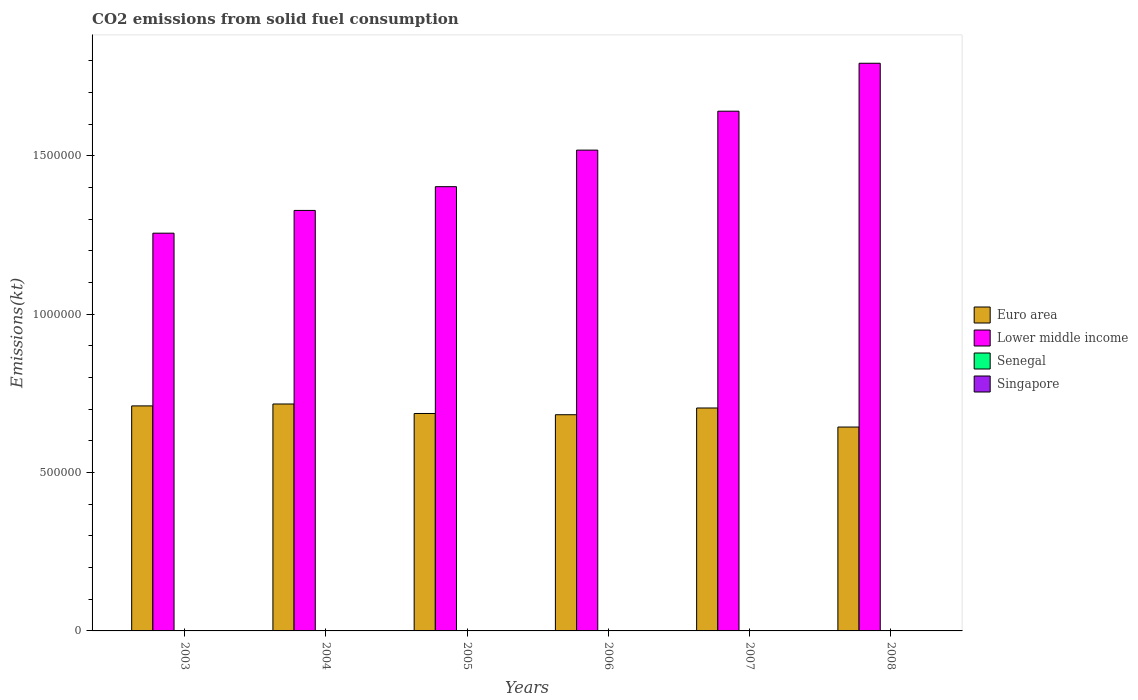Are the number of bars on each tick of the X-axis equal?
Ensure brevity in your answer.  Yes. How many bars are there on the 3rd tick from the left?
Provide a succinct answer. 4. In how many cases, is the number of bars for a given year not equal to the number of legend labels?
Offer a terse response. 0. What is the amount of CO2 emitted in Senegal in 2003?
Your answer should be very brief. 319.03. Across all years, what is the maximum amount of CO2 emitted in Senegal?
Provide a succinct answer. 799.41. Across all years, what is the minimum amount of CO2 emitted in Lower middle income?
Your answer should be compact. 1.26e+06. In which year was the amount of CO2 emitted in Senegal maximum?
Your response must be concise. 2007. In which year was the amount of CO2 emitted in Euro area minimum?
Provide a succinct answer. 2008. What is the total amount of CO2 emitted in Senegal in the graph?
Your response must be concise. 3135.29. What is the difference between the amount of CO2 emitted in Singapore in 2004 and that in 2007?
Offer a terse response. 14.67. What is the difference between the amount of CO2 emitted in Euro area in 2005 and the amount of CO2 emitted in Senegal in 2006?
Provide a short and direct response. 6.86e+05. What is the average amount of CO2 emitted in Senegal per year?
Provide a short and direct response. 522.55. In the year 2006, what is the difference between the amount of CO2 emitted in Euro area and amount of CO2 emitted in Lower middle income?
Keep it short and to the point. -8.35e+05. In how many years, is the amount of CO2 emitted in Euro area greater than 1300000 kt?
Make the answer very short. 0. What is the ratio of the amount of CO2 emitted in Lower middle income in 2004 to that in 2008?
Make the answer very short. 0.74. What is the difference between the highest and the second highest amount of CO2 emitted in Euro area?
Offer a terse response. 6039.28. What is the difference between the highest and the lowest amount of CO2 emitted in Lower middle income?
Your answer should be compact. 5.36e+05. In how many years, is the amount of CO2 emitted in Lower middle income greater than the average amount of CO2 emitted in Lower middle income taken over all years?
Keep it short and to the point. 3. Is the sum of the amount of CO2 emitted in Lower middle income in 2004 and 2008 greater than the maximum amount of CO2 emitted in Senegal across all years?
Make the answer very short. Yes. Is it the case that in every year, the sum of the amount of CO2 emitted in Euro area and amount of CO2 emitted in Lower middle income is greater than the sum of amount of CO2 emitted in Senegal and amount of CO2 emitted in Singapore?
Provide a succinct answer. No. What does the 1st bar from the left in 2003 represents?
Give a very brief answer. Euro area. What does the 4th bar from the right in 2008 represents?
Keep it short and to the point. Euro area. What is the difference between two consecutive major ticks on the Y-axis?
Offer a very short reply. 5.00e+05. Does the graph contain any zero values?
Offer a very short reply. No. Does the graph contain grids?
Offer a terse response. No. What is the title of the graph?
Offer a very short reply. CO2 emissions from solid fuel consumption. Does "Papua New Guinea" appear as one of the legend labels in the graph?
Your answer should be compact. No. What is the label or title of the Y-axis?
Provide a succinct answer. Emissions(kt). What is the Emissions(kt) in Euro area in 2003?
Your answer should be compact. 7.10e+05. What is the Emissions(kt) of Lower middle income in 2003?
Give a very brief answer. 1.26e+06. What is the Emissions(kt) in Senegal in 2003?
Keep it short and to the point. 319.03. What is the Emissions(kt) in Singapore in 2003?
Provide a short and direct response. 33. What is the Emissions(kt) of Euro area in 2004?
Your response must be concise. 7.16e+05. What is the Emissions(kt) of Lower middle income in 2004?
Ensure brevity in your answer.  1.33e+06. What is the Emissions(kt) of Senegal in 2004?
Provide a short and direct response. 418.04. What is the Emissions(kt) of Singapore in 2004?
Ensure brevity in your answer.  40.34. What is the Emissions(kt) of Euro area in 2005?
Provide a short and direct response. 6.86e+05. What is the Emissions(kt) of Lower middle income in 2005?
Give a very brief answer. 1.40e+06. What is the Emissions(kt) of Senegal in 2005?
Your response must be concise. 418.04. What is the Emissions(kt) in Singapore in 2005?
Keep it short and to the point. 11. What is the Emissions(kt) in Euro area in 2006?
Your response must be concise. 6.82e+05. What is the Emissions(kt) in Lower middle income in 2006?
Give a very brief answer. 1.52e+06. What is the Emissions(kt) of Senegal in 2006?
Make the answer very short. 506.05. What is the Emissions(kt) in Singapore in 2006?
Provide a succinct answer. 14.67. What is the Emissions(kt) in Euro area in 2007?
Make the answer very short. 7.04e+05. What is the Emissions(kt) of Lower middle income in 2007?
Provide a short and direct response. 1.64e+06. What is the Emissions(kt) of Senegal in 2007?
Give a very brief answer. 799.41. What is the Emissions(kt) of Singapore in 2007?
Make the answer very short. 25.67. What is the Emissions(kt) in Euro area in 2008?
Offer a very short reply. 6.44e+05. What is the Emissions(kt) of Lower middle income in 2008?
Your answer should be compact. 1.79e+06. What is the Emissions(kt) of Senegal in 2008?
Provide a short and direct response. 674.73. What is the Emissions(kt) of Singapore in 2008?
Provide a short and direct response. 18.34. Across all years, what is the maximum Emissions(kt) in Euro area?
Ensure brevity in your answer.  7.16e+05. Across all years, what is the maximum Emissions(kt) in Lower middle income?
Your answer should be very brief. 1.79e+06. Across all years, what is the maximum Emissions(kt) of Senegal?
Make the answer very short. 799.41. Across all years, what is the maximum Emissions(kt) in Singapore?
Your response must be concise. 40.34. Across all years, what is the minimum Emissions(kt) of Euro area?
Provide a short and direct response. 6.44e+05. Across all years, what is the minimum Emissions(kt) in Lower middle income?
Offer a very short reply. 1.26e+06. Across all years, what is the minimum Emissions(kt) of Senegal?
Offer a very short reply. 319.03. Across all years, what is the minimum Emissions(kt) of Singapore?
Offer a terse response. 11. What is the total Emissions(kt) of Euro area in the graph?
Your response must be concise. 4.14e+06. What is the total Emissions(kt) of Lower middle income in the graph?
Your response must be concise. 8.93e+06. What is the total Emissions(kt) of Senegal in the graph?
Your answer should be very brief. 3135.28. What is the total Emissions(kt) in Singapore in the graph?
Make the answer very short. 143.01. What is the difference between the Emissions(kt) in Euro area in 2003 and that in 2004?
Ensure brevity in your answer.  -6039.27. What is the difference between the Emissions(kt) in Lower middle income in 2003 and that in 2004?
Your response must be concise. -7.18e+04. What is the difference between the Emissions(kt) in Senegal in 2003 and that in 2004?
Provide a short and direct response. -99.01. What is the difference between the Emissions(kt) of Singapore in 2003 and that in 2004?
Offer a terse response. -7.33. What is the difference between the Emissions(kt) of Euro area in 2003 and that in 2005?
Ensure brevity in your answer.  2.40e+04. What is the difference between the Emissions(kt) in Lower middle income in 2003 and that in 2005?
Your answer should be compact. -1.47e+05. What is the difference between the Emissions(kt) of Senegal in 2003 and that in 2005?
Make the answer very short. -99.01. What is the difference between the Emissions(kt) in Singapore in 2003 and that in 2005?
Your answer should be compact. 22. What is the difference between the Emissions(kt) of Euro area in 2003 and that in 2006?
Give a very brief answer. 2.78e+04. What is the difference between the Emissions(kt) in Lower middle income in 2003 and that in 2006?
Provide a short and direct response. -2.62e+05. What is the difference between the Emissions(kt) in Senegal in 2003 and that in 2006?
Offer a very short reply. -187.02. What is the difference between the Emissions(kt) of Singapore in 2003 and that in 2006?
Offer a terse response. 18.34. What is the difference between the Emissions(kt) of Euro area in 2003 and that in 2007?
Provide a short and direct response. 6607.98. What is the difference between the Emissions(kt) in Lower middle income in 2003 and that in 2007?
Ensure brevity in your answer.  -3.85e+05. What is the difference between the Emissions(kt) in Senegal in 2003 and that in 2007?
Your response must be concise. -480.38. What is the difference between the Emissions(kt) of Singapore in 2003 and that in 2007?
Provide a succinct answer. 7.33. What is the difference between the Emissions(kt) in Euro area in 2003 and that in 2008?
Offer a terse response. 6.67e+04. What is the difference between the Emissions(kt) of Lower middle income in 2003 and that in 2008?
Offer a very short reply. -5.36e+05. What is the difference between the Emissions(kt) of Senegal in 2003 and that in 2008?
Offer a terse response. -355.7. What is the difference between the Emissions(kt) of Singapore in 2003 and that in 2008?
Give a very brief answer. 14.67. What is the difference between the Emissions(kt) of Euro area in 2004 and that in 2005?
Make the answer very short. 3.00e+04. What is the difference between the Emissions(kt) of Lower middle income in 2004 and that in 2005?
Your answer should be compact. -7.50e+04. What is the difference between the Emissions(kt) in Senegal in 2004 and that in 2005?
Provide a succinct answer. 0. What is the difference between the Emissions(kt) of Singapore in 2004 and that in 2005?
Your response must be concise. 29.34. What is the difference between the Emissions(kt) of Euro area in 2004 and that in 2006?
Your answer should be compact. 3.39e+04. What is the difference between the Emissions(kt) of Lower middle income in 2004 and that in 2006?
Your response must be concise. -1.90e+05. What is the difference between the Emissions(kt) of Senegal in 2004 and that in 2006?
Make the answer very short. -88.01. What is the difference between the Emissions(kt) in Singapore in 2004 and that in 2006?
Your answer should be compact. 25.67. What is the difference between the Emissions(kt) of Euro area in 2004 and that in 2007?
Offer a very short reply. 1.26e+04. What is the difference between the Emissions(kt) in Lower middle income in 2004 and that in 2007?
Give a very brief answer. -3.13e+05. What is the difference between the Emissions(kt) of Senegal in 2004 and that in 2007?
Your answer should be very brief. -381.37. What is the difference between the Emissions(kt) in Singapore in 2004 and that in 2007?
Your response must be concise. 14.67. What is the difference between the Emissions(kt) of Euro area in 2004 and that in 2008?
Your answer should be very brief. 7.28e+04. What is the difference between the Emissions(kt) in Lower middle income in 2004 and that in 2008?
Keep it short and to the point. -4.65e+05. What is the difference between the Emissions(kt) of Senegal in 2004 and that in 2008?
Your answer should be compact. -256.69. What is the difference between the Emissions(kt) in Singapore in 2004 and that in 2008?
Give a very brief answer. 22. What is the difference between the Emissions(kt) in Euro area in 2005 and that in 2006?
Ensure brevity in your answer.  3892.87. What is the difference between the Emissions(kt) of Lower middle income in 2005 and that in 2006?
Give a very brief answer. -1.15e+05. What is the difference between the Emissions(kt) of Senegal in 2005 and that in 2006?
Your answer should be compact. -88.01. What is the difference between the Emissions(kt) of Singapore in 2005 and that in 2006?
Provide a short and direct response. -3.67. What is the difference between the Emissions(kt) in Euro area in 2005 and that in 2007?
Give a very brief answer. -1.73e+04. What is the difference between the Emissions(kt) of Lower middle income in 2005 and that in 2007?
Your response must be concise. -2.38e+05. What is the difference between the Emissions(kt) in Senegal in 2005 and that in 2007?
Offer a very short reply. -381.37. What is the difference between the Emissions(kt) of Singapore in 2005 and that in 2007?
Your answer should be compact. -14.67. What is the difference between the Emissions(kt) of Euro area in 2005 and that in 2008?
Provide a succinct answer. 4.28e+04. What is the difference between the Emissions(kt) in Lower middle income in 2005 and that in 2008?
Your answer should be very brief. -3.90e+05. What is the difference between the Emissions(kt) in Senegal in 2005 and that in 2008?
Ensure brevity in your answer.  -256.69. What is the difference between the Emissions(kt) of Singapore in 2005 and that in 2008?
Your response must be concise. -7.33. What is the difference between the Emissions(kt) of Euro area in 2006 and that in 2007?
Keep it short and to the point. -2.12e+04. What is the difference between the Emissions(kt) in Lower middle income in 2006 and that in 2007?
Make the answer very short. -1.23e+05. What is the difference between the Emissions(kt) in Senegal in 2006 and that in 2007?
Provide a succinct answer. -293.36. What is the difference between the Emissions(kt) in Singapore in 2006 and that in 2007?
Your answer should be compact. -11. What is the difference between the Emissions(kt) of Euro area in 2006 and that in 2008?
Your response must be concise. 3.89e+04. What is the difference between the Emissions(kt) of Lower middle income in 2006 and that in 2008?
Provide a short and direct response. -2.74e+05. What is the difference between the Emissions(kt) in Senegal in 2006 and that in 2008?
Make the answer very short. -168.68. What is the difference between the Emissions(kt) in Singapore in 2006 and that in 2008?
Offer a terse response. -3.67. What is the difference between the Emissions(kt) of Euro area in 2007 and that in 2008?
Give a very brief answer. 6.01e+04. What is the difference between the Emissions(kt) in Lower middle income in 2007 and that in 2008?
Make the answer very short. -1.51e+05. What is the difference between the Emissions(kt) in Senegal in 2007 and that in 2008?
Give a very brief answer. 124.68. What is the difference between the Emissions(kt) in Singapore in 2007 and that in 2008?
Provide a succinct answer. 7.33. What is the difference between the Emissions(kt) of Euro area in 2003 and the Emissions(kt) of Lower middle income in 2004?
Your answer should be compact. -6.17e+05. What is the difference between the Emissions(kt) of Euro area in 2003 and the Emissions(kt) of Senegal in 2004?
Provide a short and direct response. 7.10e+05. What is the difference between the Emissions(kt) in Euro area in 2003 and the Emissions(kt) in Singapore in 2004?
Your answer should be very brief. 7.10e+05. What is the difference between the Emissions(kt) in Lower middle income in 2003 and the Emissions(kt) in Senegal in 2004?
Keep it short and to the point. 1.26e+06. What is the difference between the Emissions(kt) in Lower middle income in 2003 and the Emissions(kt) in Singapore in 2004?
Offer a terse response. 1.26e+06. What is the difference between the Emissions(kt) in Senegal in 2003 and the Emissions(kt) in Singapore in 2004?
Give a very brief answer. 278.69. What is the difference between the Emissions(kt) of Euro area in 2003 and the Emissions(kt) of Lower middle income in 2005?
Provide a short and direct response. -6.92e+05. What is the difference between the Emissions(kt) in Euro area in 2003 and the Emissions(kt) in Senegal in 2005?
Your answer should be compact. 7.10e+05. What is the difference between the Emissions(kt) of Euro area in 2003 and the Emissions(kt) of Singapore in 2005?
Offer a terse response. 7.10e+05. What is the difference between the Emissions(kt) in Lower middle income in 2003 and the Emissions(kt) in Senegal in 2005?
Keep it short and to the point. 1.26e+06. What is the difference between the Emissions(kt) in Lower middle income in 2003 and the Emissions(kt) in Singapore in 2005?
Offer a terse response. 1.26e+06. What is the difference between the Emissions(kt) in Senegal in 2003 and the Emissions(kt) in Singapore in 2005?
Offer a terse response. 308.03. What is the difference between the Emissions(kt) in Euro area in 2003 and the Emissions(kt) in Lower middle income in 2006?
Your answer should be compact. -8.07e+05. What is the difference between the Emissions(kt) of Euro area in 2003 and the Emissions(kt) of Senegal in 2006?
Make the answer very short. 7.10e+05. What is the difference between the Emissions(kt) of Euro area in 2003 and the Emissions(kt) of Singapore in 2006?
Your answer should be very brief. 7.10e+05. What is the difference between the Emissions(kt) of Lower middle income in 2003 and the Emissions(kt) of Senegal in 2006?
Provide a succinct answer. 1.25e+06. What is the difference between the Emissions(kt) in Lower middle income in 2003 and the Emissions(kt) in Singapore in 2006?
Make the answer very short. 1.26e+06. What is the difference between the Emissions(kt) of Senegal in 2003 and the Emissions(kt) of Singapore in 2006?
Provide a short and direct response. 304.36. What is the difference between the Emissions(kt) of Euro area in 2003 and the Emissions(kt) of Lower middle income in 2007?
Make the answer very short. -9.30e+05. What is the difference between the Emissions(kt) in Euro area in 2003 and the Emissions(kt) in Senegal in 2007?
Your answer should be very brief. 7.09e+05. What is the difference between the Emissions(kt) of Euro area in 2003 and the Emissions(kt) of Singapore in 2007?
Offer a very short reply. 7.10e+05. What is the difference between the Emissions(kt) in Lower middle income in 2003 and the Emissions(kt) in Senegal in 2007?
Provide a short and direct response. 1.25e+06. What is the difference between the Emissions(kt) in Lower middle income in 2003 and the Emissions(kt) in Singapore in 2007?
Offer a terse response. 1.26e+06. What is the difference between the Emissions(kt) in Senegal in 2003 and the Emissions(kt) in Singapore in 2007?
Give a very brief answer. 293.36. What is the difference between the Emissions(kt) in Euro area in 2003 and the Emissions(kt) in Lower middle income in 2008?
Ensure brevity in your answer.  -1.08e+06. What is the difference between the Emissions(kt) of Euro area in 2003 and the Emissions(kt) of Senegal in 2008?
Give a very brief answer. 7.10e+05. What is the difference between the Emissions(kt) of Euro area in 2003 and the Emissions(kt) of Singapore in 2008?
Provide a succinct answer. 7.10e+05. What is the difference between the Emissions(kt) of Lower middle income in 2003 and the Emissions(kt) of Senegal in 2008?
Give a very brief answer. 1.25e+06. What is the difference between the Emissions(kt) in Lower middle income in 2003 and the Emissions(kt) in Singapore in 2008?
Your response must be concise. 1.26e+06. What is the difference between the Emissions(kt) of Senegal in 2003 and the Emissions(kt) of Singapore in 2008?
Your answer should be compact. 300.69. What is the difference between the Emissions(kt) of Euro area in 2004 and the Emissions(kt) of Lower middle income in 2005?
Ensure brevity in your answer.  -6.86e+05. What is the difference between the Emissions(kt) in Euro area in 2004 and the Emissions(kt) in Senegal in 2005?
Ensure brevity in your answer.  7.16e+05. What is the difference between the Emissions(kt) of Euro area in 2004 and the Emissions(kt) of Singapore in 2005?
Your response must be concise. 7.16e+05. What is the difference between the Emissions(kt) in Lower middle income in 2004 and the Emissions(kt) in Senegal in 2005?
Offer a terse response. 1.33e+06. What is the difference between the Emissions(kt) of Lower middle income in 2004 and the Emissions(kt) of Singapore in 2005?
Provide a short and direct response. 1.33e+06. What is the difference between the Emissions(kt) in Senegal in 2004 and the Emissions(kt) in Singapore in 2005?
Your answer should be compact. 407.04. What is the difference between the Emissions(kt) of Euro area in 2004 and the Emissions(kt) of Lower middle income in 2006?
Your answer should be very brief. -8.01e+05. What is the difference between the Emissions(kt) in Euro area in 2004 and the Emissions(kt) in Senegal in 2006?
Make the answer very short. 7.16e+05. What is the difference between the Emissions(kt) of Euro area in 2004 and the Emissions(kt) of Singapore in 2006?
Keep it short and to the point. 7.16e+05. What is the difference between the Emissions(kt) in Lower middle income in 2004 and the Emissions(kt) in Senegal in 2006?
Ensure brevity in your answer.  1.33e+06. What is the difference between the Emissions(kt) in Lower middle income in 2004 and the Emissions(kt) in Singapore in 2006?
Your answer should be very brief. 1.33e+06. What is the difference between the Emissions(kt) of Senegal in 2004 and the Emissions(kt) of Singapore in 2006?
Offer a very short reply. 403.37. What is the difference between the Emissions(kt) in Euro area in 2004 and the Emissions(kt) in Lower middle income in 2007?
Offer a terse response. -9.24e+05. What is the difference between the Emissions(kt) in Euro area in 2004 and the Emissions(kt) in Senegal in 2007?
Your answer should be very brief. 7.16e+05. What is the difference between the Emissions(kt) of Euro area in 2004 and the Emissions(kt) of Singapore in 2007?
Provide a succinct answer. 7.16e+05. What is the difference between the Emissions(kt) of Lower middle income in 2004 and the Emissions(kt) of Senegal in 2007?
Your response must be concise. 1.33e+06. What is the difference between the Emissions(kt) of Lower middle income in 2004 and the Emissions(kt) of Singapore in 2007?
Provide a succinct answer. 1.33e+06. What is the difference between the Emissions(kt) in Senegal in 2004 and the Emissions(kt) in Singapore in 2007?
Provide a short and direct response. 392.37. What is the difference between the Emissions(kt) in Euro area in 2004 and the Emissions(kt) in Lower middle income in 2008?
Give a very brief answer. -1.08e+06. What is the difference between the Emissions(kt) in Euro area in 2004 and the Emissions(kt) in Senegal in 2008?
Your answer should be very brief. 7.16e+05. What is the difference between the Emissions(kt) in Euro area in 2004 and the Emissions(kt) in Singapore in 2008?
Offer a terse response. 7.16e+05. What is the difference between the Emissions(kt) of Lower middle income in 2004 and the Emissions(kt) of Senegal in 2008?
Provide a succinct answer. 1.33e+06. What is the difference between the Emissions(kt) of Lower middle income in 2004 and the Emissions(kt) of Singapore in 2008?
Provide a succinct answer. 1.33e+06. What is the difference between the Emissions(kt) of Senegal in 2004 and the Emissions(kt) of Singapore in 2008?
Offer a terse response. 399.7. What is the difference between the Emissions(kt) in Euro area in 2005 and the Emissions(kt) in Lower middle income in 2006?
Offer a terse response. -8.31e+05. What is the difference between the Emissions(kt) of Euro area in 2005 and the Emissions(kt) of Senegal in 2006?
Keep it short and to the point. 6.86e+05. What is the difference between the Emissions(kt) of Euro area in 2005 and the Emissions(kt) of Singapore in 2006?
Your response must be concise. 6.86e+05. What is the difference between the Emissions(kt) of Lower middle income in 2005 and the Emissions(kt) of Senegal in 2006?
Keep it short and to the point. 1.40e+06. What is the difference between the Emissions(kt) in Lower middle income in 2005 and the Emissions(kt) in Singapore in 2006?
Make the answer very short. 1.40e+06. What is the difference between the Emissions(kt) of Senegal in 2005 and the Emissions(kt) of Singapore in 2006?
Provide a succinct answer. 403.37. What is the difference between the Emissions(kt) of Euro area in 2005 and the Emissions(kt) of Lower middle income in 2007?
Provide a succinct answer. -9.54e+05. What is the difference between the Emissions(kt) of Euro area in 2005 and the Emissions(kt) of Senegal in 2007?
Ensure brevity in your answer.  6.86e+05. What is the difference between the Emissions(kt) in Euro area in 2005 and the Emissions(kt) in Singapore in 2007?
Provide a succinct answer. 6.86e+05. What is the difference between the Emissions(kt) of Lower middle income in 2005 and the Emissions(kt) of Senegal in 2007?
Offer a terse response. 1.40e+06. What is the difference between the Emissions(kt) of Lower middle income in 2005 and the Emissions(kt) of Singapore in 2007?
Keep it short and to the point. 1.40e+06. What is the difference between the Emissions(kt) in Senegal in 2005 and the Emissions(kt) in Singapore in 2007?
Your answer should be compact. 392.37. What is the difference between the Emissions(kt) of Euro area in 2005 and the Emissions(kt) of Lower middle income in 2008?
Your response must be concise. -1.11e+06. What is the difference between the Emissions(kt) of Euro area in 2005 and the Emissions(kt) of Senegal in 2008?
Offer a very short reply. 6.86e+05. What is the difference between the Emissions(kt) of Euro area in 2005 and the Emissions(kt) of Singapore in 2008?
Provide a short and direct response. 6.86e+05. What is the difference between the Emissions(kt) in Lower middle income in 2005 and the Emissions(kt) in Senegal in 2008?
Make the answer very short. 1.40e+06. What is the difference between the Emissions(kt) of Lower middle income in 2005 and the Emissions(kt) of Singapore in 2008?
Your response must be concise. 1.40e+06. What is the difference between the Emissions(kt) of Senegal in 2005 and the Emissions(kt) of Singapore in 2008?
Make the answer very short. 399.7. What is the difference between the Emissions(kt) of Euro area in 2006 and the Emissions(kt) of Lower middle income in 2007?
Provide a succinct answer. -9.58e+05. What is the difference between the Emissions(kt) of Euro area in 2006 and the Emissions(kt) of Senegal in 2007?
Your response must be concise. 6.82e+05. What is the difference between the Emissions(kt) in Euro area in 2006 and the Emissions(kt) in Singapore in 2007?
Give a very brief answer. 6.82e+05. What is the difference between the Emissions(kt) in Lower middle income in 2006 and the Emissions(kt) in Senegal in 2007?
Give a very brief answer. 1.52e+06. What is the difference between the Emissions(kt) in Lower middle income in 2006 and the Emissions(kt) in Singapore in 2007?
Make the answer very short. 1.52e+06. What is the difference between the Emissions(kt) of Senegal in 2006 and the Emissions(kt) of Singapore in 2007?
Ensure brevity in your answer.  480.38. What is the difference between the Emissions(kt) of Euro area in 2006 and the Emissions(kt) of Lower middle income in 2008?
Offer a terse response. -1.11e+06. What is the difference between the Emissions(kt) of Euro area in 2006 and the Emissions(kt) of Senegal in 2008?
Provide a succinct answer. 6.82e+05. What is the difference between the Emissions(kt) of Euro area in 2006 and the Emissions(kt) of Singapore in 2008?
Ensure brevity in your answer.  6.82e+05. What is the difference between the Emissions(kt) in Lower middle income in 2006 and the Emissions(kt) in Senegal in 2008?
Ensure brevity in your answer.  1.52e+06. What is the difference between the Emissions(kt) of Lower middle income in 2006 and the Emissions(kt) of Singapore in 2008?
Your answer should be compact. 1.52e+06. What is the difference between the Emissions(kt) in Senegal in 2006 and the Emissions(kt) in Singapore in 2008?
Ensure brevity in your answer.  487.71. What is the difference between the Emissions(kt) of Euro area in 2007 and the Emissions(kt) of Lower middle income in 2008?
Give a very brief answer. -1.09e+06. What is the difference between the Emissions(kt) in Euro area in 2007 and the Emissions(kt) in Senegal in 2008?
Keep it short and to the point. 7.03e+05. What is the difference between the Emissions(kt) of Euro area in 2007 and the Emissions(kt) of Singapore in 2008?
Ensure brevity in your answer.  7.04e+05. What is the difference between the Emissions(kt) of Lower middle income in 2007 and the Emissions(kt) of Senegal in 2008?
Make the answer very short. 1.64e+06. What is the difference between the Emissions(kt) in Lower middle income in 2007 and the Emissions(kt) in Singapore in 2008?
Offer a terse response. 1.64e+06. What is the difference between the Emissions(kt) of Senegal in 2007 and the Emissions(kt) of Singapore in 2008?
Keep it short and to the point. 781.07. What is the average Emissions(kt) in Euro area per year?
Your response must be concise. 6.90e+05. What is the average Emissions(kt) in Lower middle income per year?
Your response must be concise. 1.49e+06. What is the average Emissions(kt) of Senegal per year?
Provide a succinct answer. 522.55. What is the average Emissions(kt) of Singapore per year?
Offer a terse response. 23.84. In the year 2003, what is the difference between the Emissions(kt) in Euro area and Emissions(kt) in Lower middle income?
Give a very brief answer. -5.45e+05. In the year 2003, what is the difference between the Emissions(kt) of Euro area and Emissions(kt) of Senegal?
Ensure brevity in your answer.  7.10e+05. In the year 2003, what is the difference between the Emissions(kt) of Euro area and Emissions(kt) of Singapore?
Your response must be concise. 7.10e+05. In the year 2003, what is the difference between the Emissions(kt) in Lower middle income and Emissions(kt) in Senegal?
Offer a very short reply. 1.26e+06. In the year 2003, what is the difference between the Emissions(kt) of Lower middle income and Emissions(kt) of Singapore?
Ensure brevity in your answer.  1.26e+06. In the year 2003, what is the difference between the Emissions(kt) of Senegal and Emissions(kt) of Singapore?
Your response must be concise. 286.03. In the year 2004, what is the difference between the Emissions(kt) of Euro area and Emissions(kt) of Lower middle income?
Provide a succinct answer. -6.11e+05. In the year 2004, what is the difference between the Emissions(kt) of Euro area and Emissions(kt) of Senegal?
Offer a terse response. 7.16e+05. In the year 2004, what is the difference between the Emissions(kt) in Euro area and Emissions(kt) in Singapore?
Keep it short and to the point. 7.16e+05. In the year 2004, what is the difference between the Emissions(kt) in Lower middle income and Emissions(kt) in Senegal?
Offer a terse response. 1.33e+06. In the year 2004, what is the difference between the Emissions(kt) in Lower middle income and Emissions(kt) in Singapore?
Ensure brevity in your answer.  1.33e+06. In the year 2004, what is the difference between the Emissions(kt) in Senegal and Emissions(kt) in Singapore?
Provide a short and direct response. 377.7. In the year 2005, what is the difference between the Emissions(kt) in Euro area and Emissions(kt) in Lower middle income?
Offer a very short reply. -7.16e+05. In the year 2005, what is the difference between the Emissions(kt) of Euro area and Emissions(kt) of Senegal?
Ensure brevity in your answer.  6.86e+05. In the year 2005, what is the difference between the Emissions(kt) in Euro area and Emissions(kt) in Singapore?
Offer a terse response. 6.86e+05. In the year 2005, what is the difference between the Emissions(kt) of Lower middle income and Emissions(kt) of Senegal?
Make the answer very short. 1.40e+06. In the year 2005, what is the difference between the Emissions(kt) of Lower middle income and Emissions(kt) of Singapore?
Your response must be concise. 1.40e+06. In the year 2005, what is the difference between the Emissions(kt) in Senegal and Emissions(kt) in Singapore?
Give a very brief answer. 407.04. In the year 2006, what is the difference between the Emissions(kt) of Euro area and Emissions(kt) of Lower middle income?
Make the answer very short. -8.35e+05. In the year 2006, what is the difference between the Emissions(kt) in Euro area and Emissions(kt) in Senegal?
Give a very brief answer. 6.82e+05. In the year 2006, what is the difference between the Emissions(kt) in Euro area and Emissions(kt) in Singapore?
Provide a succinct answer. 6.82e+05. In the year 2006, what is the difference between the Emissions(kt) of Lower middle income and Emissions(kt) of Senegal?
Give a very brief answer. 1.52e+06. In the year 2006, what is the difference between the Emissions(kt) of Lower middle income and Emissions(kt) of Singapore?
Provide a succinct answer. 1.52e+06. In the year 2006, what is the difference between the Emissions(kt) of Senegal and Emissions(kt) of Singapore?
Provide a succinct answer. 491.38. In the year 2007, what is the difference between the Emissions(kt) of Euro area and Emissions(kt) of Lower middle income?
Give a very brief answer. -9.37e+05. In the year 2007, what is the difference between the Emissions(kt) of Euro area and Emissions(kt) of Senegal?
Make the answer very short. 7.03e+05. In the year 2007, what is the difference between the Emissions(kt) of Euro area and Emissions(kt) of Singapore?
Give a very brief answer. 7.04e+05. In the year 2007, what is the difference between the Emissions(kt) in Lower middle income and Emissions(kt) in Senegal?
Ensure brevity in your answer.  1.64e+06. In the year 2007, what is the difference between the Emissions(kt) of Lower middle income and Emissions(kt) of Singapore?
Your response must be concise. 1.64e+06. In the year 2007, what is the difference between the Emissions(kt) in Senegal and Emissions(kt) in Singapore?
Your answer should be very brief. 773.74. In the year 2008, what is the difference between the Emissions(kt) of Euro area and Emissions(kt) of Lower middle income?
Your response must be concise. -1.15e+06. In the year 2008, what is the difference between the Emissions(kt) of Euro area and Emissions(kt) of Senegal?
Provide a short and direct response. 6.43e+05. In the year 2008, what is the difference between the Emissions(kt) in Euro area and Emissions(kt) in Singapore?
Your response must be concise. 6.44e+05. In the year 2008, what is the difference between the Emissions(kt) of Lower middle income and Emissions(kt) of Senegal?
Keep it short and to the point. 1.79e+06. In the year 2008, what is the difference between the Emissions(kt) in Lower middle income and Emissions(kt) in Singapore?
Ensure brevity in your answer.  1.79e+06. In the year 2008, what is the difference between the Emissions(kt) in Senegal and Emissions(kt) in Singapore?
Keep it short and to the point. 656.39. What is the ratio of the Emissions(kt) in Lower middle income in 2003 to that in 2004?
Give a very brief answer. 0.95. What is the ratio of the Emissions(kt) in Senegal in 2003 to that in 2004?
Give a very brief answer. 0.76. What is the ratio of the Emissions(kt) in Singapore in 2003 to that in 2004?
Make the answer very short. 0.82. What is the ratio of the Emissions(kt) in Euro area in 2003 to that in 2005?
Keep it short and to the point. 1.03. What is the ratio of the Emissions(kt) of Lower middle income in 2003 to that in 2005?
Your response must be concise. 0.9. What is the ratio of the Emissions(kt) in Senegal in 2003 to that in 2005?
Your answer should be very brief. 0.76. What is the ratio of the Emissions(kt) of Euro area in 2003 to that in 2006?
Your answer should be very brief. 1.04. What is the ratio of the Emissions(kt) of Lower middle income in 2003 to that in 2006?
Provide a succinct answer. 0.83. What is the ratio of the Emissions(kt) in Senegal in 2003 to that in 2006?
Provide a short and direct response. 0.63. What is the ratio of the Emissions(kt) in Singapore in 2003 to that in 2006?
Your answer should be compact. 2.25. What is the ratio of the Emissions(kt) of Euro area in 2003 to that in 2007?
Offer a very short reply. 1.01. What is the ratio of the Emissions(kt) in Lower middle income in 2003 to that in 2007?
Provide a succinct answer. 0.77. What is the ratio of the Emissions(kt) of Senegal in 2003 to that in 2007?
Make the answer very short. 0.4. What is the ratio of the Emissions(kt) of Singapore in 2003 to that in 2007?
Ensure brevity in your answer.  1.29. What is the ratio of the Emissions(kt) of Euro area in 2003 to that in 2008?
Your answer should be very brief. 1.1. What is the ratio of the Emissions(kt) of Lower middle income in 2003 to that in 2008?
Offer a very short reply. 0.7. What is the ratio of the Emissions(kt) of Senegal in 2003 to that in 2008?
Offer a very short reply. 0.47. What is the ratio of the Emissions(kt) of Singapore in 2003 to that in 2008?
Offer a terse response. 1.8. What is the ratio of the Emissions(kt) of Euro area in 2004 to that in 2005?
Your response must be concise. 1.04. What is the ratio of the Emissions(kt) of Lower middle income in 2004 to that in 2005?
Your answer should be compact. 0.95. What is the ratio of the Emissions(kt) of Senegal in 2004 to that in 2005?
Offer a terse response. 1. What is the ratio of the Emissions(kt) of Singapore in 2004 to that in 2005?
Offer a terse response. 3.67. What is the ratio of the Emissions(kt) of Euro area in 2004 to that in 2006?
Offer a very short reply. 1.05. What is the ratio of the Emissions(kt) in Lower middle income in 2004 to that in 2006?
Offer a very short reply. 0.87. What is the ratio of the Emissions(kt) of Senegal in 2004 to that in 2006?
Keep it short and to the point. 0.83. What is the ratio of the Emissions(kt) in Singapore in 2004 to that in 2006?
Provide a succinct answer. 2.75. What is the ratio of the Emissions(kt) in Euro area in 2004 to that in 2007?
Your response must be concise. 1.02. What is the ratio of the Emissions(kt) in Lower middle income in 2004 to that in 2007?
Make the answer very short. 0.81. What is the ratio of the Emissions(kt) of Senegal in 2004 to that in 2007?
Provide a succinct answer. 0.52. What is the ratio of the Emissions(kt) in Singapore in 2004 to that in 2007?
Keep it short and to the point. 1.57. What is the ratio of the Emissions(kt) in Euro area in 2004 to that in 2008?
Give a very brief answer. 1.11. What is the ratio of the Emissions(kt) of Lower middle income in 2004 to that in 2008?
Make the answer very short. 0.74. What is the ratio of the Emissions(kt) of Senegal in 2004 to that in 2008?
Your answer should be compact. 0.62. What is the ratio of the Emissions(kt) in Euro area in 2005 to that in 2006?
Offer a very short reply. 1.01. What is the ratio of the Emissions(kt) in Lower middle income in 2005 to that in 2006?
Provide a succinct answer. 0.92. What is the ratio of the Emissions(kt) in Senegal in 2005 to that in 2006?
Provide a short and direct response. 0.83. What is the ratio of the Emissions(kt) in Singapore in 2005 to that in 2006?
Your response must be concise. 0.75. What is the ratio of the Emissions(kt) in Euro area in 2005 to that in 2007?
Offer a terse response. 0.98. What is the ratio of the Emissions(kt) in Lower middle income in 2005 to that in 2007?
Your response must be concise. 0.85. What is the ratio of the Emissions(kt) of Senegal in 2005 to that in 2007?
Your response must be concise. 0.52. What is the ratio of the Emissions(kt) in Singapore in 2005 to that in 2007?
Your answer should be very brief. 0.43. What is the ratio of the Emissions(kt) of Euro area in 2005 to that in 2008?
Ensure brevity in your answer.  1.07. What is the ratio of the Emissions(kt) of Lower middle income in 2005 to that in 2008?
Make the answer very short. 0.78. What is the ratio of the Emissions(kt) in Senegal in 2005 to that in 2008?
Provide a succinct answer. 0.62. What is the ratio of the Emissions(kt) in Singapore in 2005 to that in 2008?
Offer a terse response. 0.6. What is the ratio of the Emissions(kt) in Euro area in 2006 to that in 2007?
Your answer should be very brief. 0.97. What is the ratio of the Emissions(kt) in Lower middle income in 2006 to that in 2007?
Provide a short and direct response. 0.93. What is the ratio of the Emissions(kt) in Senegal in 2006 to that in 2007?
Provide a succinct answer. 0.63. What is the ratio of the Emissions(kt) of Singapore in 2006 to that in 2007?
Make the answer very short. 0.57. What is the ratio of the Emissions(kt) in Euro area in 2006 to that in 2008?
Provide a succinct answer. 1.06. What is the ratio of the Emissions(kt) of Lower middle income in 2006 to that in 2008?
Offer a very short reply. 0.85. What is the ratio of the Emissions(kt) in Senegal in 2006 to that in 2008?
Offer a terse response. 0.75. What is the ratio of the Emissions(kt) in Singapore in 2006 to that in 2008?
Your answer should be very brief. 0.8. What is the ratio of the Emissions(kt) in Euro area in 2007 to that in 2008?
Your answer should be compact. 1.09. What is the ratio of the Emissions(kt) of Lower middle income in 2007 to that in 2008?
Offer a very short reply. 0.92. What is the ratio of the Emissions(kt) in Senegal in 2007 to that in 2008?
Provide a short and direct response. 1.18. What is the difference between the highest and the second highest Emissions(kt) in Euro area?
Give a very brief answer. 6039.27. What is the difference between the highest and the second highest Emissions(kt) of Lower middle income?
Offer a very short reply. 1.51e+05. What is the difference between the highest and the second highest Emissions(kt) of Senegal?
Your answer should be very brief. 124.68. What is the difference between the highest and the second highest Emissions(kt) of Singapore?
Ensure brevity in your answer.  7.33. What is the difference between the highest and the lowest Emissions(kt) of Euro area?
Ensure brevity in your answer.  7.28e+04. What is the difference between the highest and the lowest Emissions(kt) of Lower middle income?
Offer a very short reply. 5.36e+05. What is the difference between the highest and the lowest Emissions(kt) in Senegal?
Make the answer very short. 480.38. What is the difference between the highest and the lowest Emissions(kt) in Singapore?
Give a very brief answer. 29.34. 